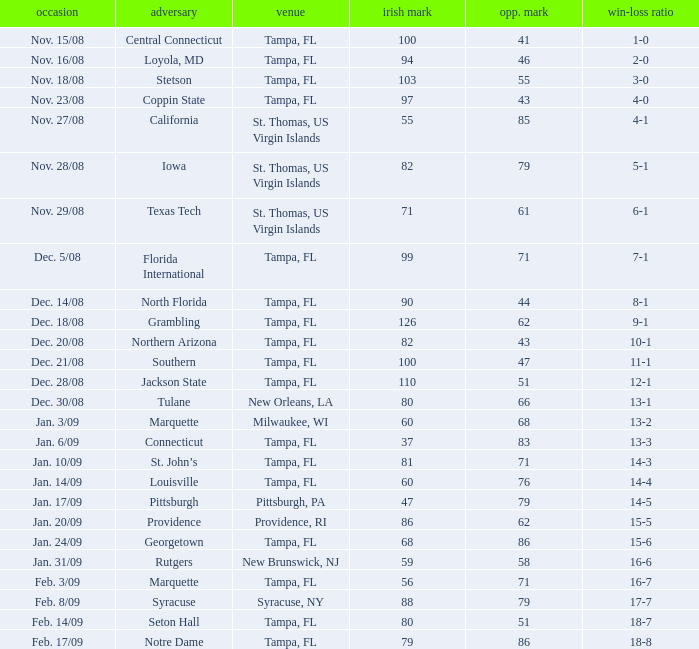I'm looking to parse the entire table for insights. Could you assist me with that? {'header': ['occasion', 'adversary', 'venue', 'irish mark', 'opp. mark', 'win-loss ratio'], 'rows': [['Nov. 15/08', 'Central Connecticut', 'Tampa, FL', '100', '41', '1-0'], ['Nov. 16/08', 'Loyola, MD', 'Tampa, FL', '94', '46', '2-0'], ['Nov. 18/08', 'Stetson', 'Tampa, FL', '103', '55', '3-0'], ['Nov. 23/08', 'Coppin State', 'Tampa, FL', '97', '43', '4-0'], ['Nov. 27/08', 'California', 'St. Thomas, US Virgin Islands', '55', '85', '4-1'], ['Nov. 28/08', 'Iowa', 'St. Thomas, US Virgin Islands', '82', '79', '5-1'], ['Nov. 29/08', 'Texas Tech', 'St. Thomas, US Virgin Islands', '71', '61', '6-1'], ['Dec. 5/08', 'Florida International', 'Tampa, FL', '99', '71', '7-1'], ['Dec. 14/08', 'North Florida', 'Tampa, FL', '90', '44', '8-1'], ['Dec. 18/08', 'Grambling', 'Tampa, FL', '126', '62', '9-1'], ['Dec. 20/08', 'Northern Arizona', 'Tampa, FL', '82', '43', '10-1'], ['Dec. 21/08', 'Southern', 'Tampa, FL', '100', '47', '11-1'], ['Dec. 28/08', 'Jackson State', 'Tampa, FL', '110', '51', '12-1'], ['Dec. 30/08', 'Tulane', 'New Orleans, LA', '80', '66', '13-1'], ['Jan. 3/09', 'Marquette', 'Milwaukee, WI', '60', '68', '13-2'], ['Jan. 6/09', 'Connecticut', 'Tampa, FL', '37', '83', '13-3'], ['Jan. 10/09', 'St. John’s', 'Tampa, FL', '81', '71', '14-3'], ['Jan. 14/09', 'Louisville', 'Tampa, FL', '60', '76', '14-4'], ['Jan. 17/09', 'Pittsburgh', 'Pittsburgh, PA', '47', '79', '14-5'], ['Jan. 20/09', 'Providence', 'Providence, RI', '86', '62', '15-5'], ['Jan. 24/09', 'Georgetown', 'Tampa, FL', '68', '86', '15-6'], ['Jan. 31/09', 'Rutgers', 'New Brunswick, NJ', '59', '58', '16-6'], ['Feb. 3/09', 'Marquette', 'Tampa, FL', '56', '71', '16-7'], ['Feb. 8/09', 'Syracuse', 'Syracuse, NY', '88', '79', '17-7'], ['Feb. 14/09', 'Seton Hall', 'Tampa, FL', '80', '51', '18-7'], ['Feb. 17/09', 'Notre Dame', 'Tampa, FL', '79', '86', '18-8']]} What is the number of opponents where the location is syracuse, ny? 1.0. 